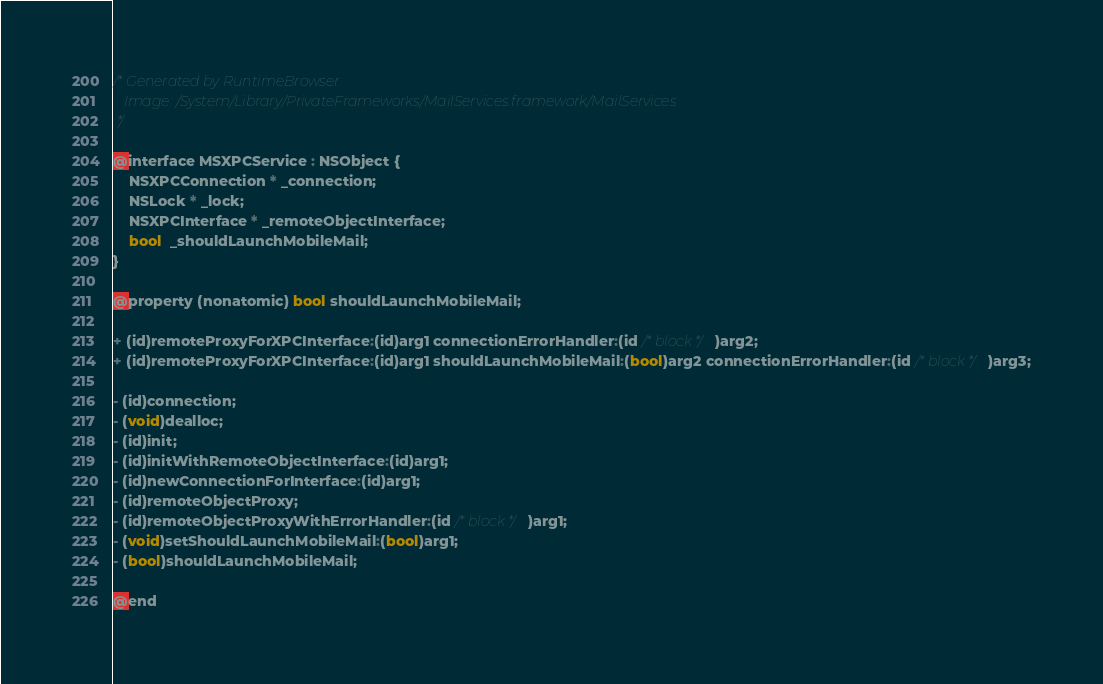<code> <loc_0><loc_0><loc_500><loc_500><_C_>/* Generated by RuntimeBrowser
   Image: /System/Library/PrivateFrameworks/MailServices.framework/MailServices
 */

@interface MSXPCService : NSObject {
    NSXPCConnection * _connection;
    NSLock * _lock;
    NSXPCInterface * _remoteObjectInterface;
    bool  _shouldLaunchMobileMail;
}

@property (nonatomic) bool shouldLaunchMobileMail;

+ (id)remoteProxyForXPCInterface:(id)arg1 connectionErrorHandler:(id /* block */)arg2;
+ (id)remoteProxyForXPCInterface:(id)arg1 shouldLaunchMobileMail:(bool)arg2 connectionErrorHandler:(id /* block */)arg3;

- (id)connection;
- (void)dealloc;
- (id)init;
- (id)initWithRemoteObjectInterface:(id)arg1;
- (id)newConnectionForInterface:(id)arg1;
- (id)remoteObjectProxy;
- (id)remoteObjectProxyWithErrorHandler:(id /* block */)arg1;
- (void)setShouldLaunchMobileMail:(bool)arg1;
- (bool)shouldLaunchMobileMail;

@end
</code> 